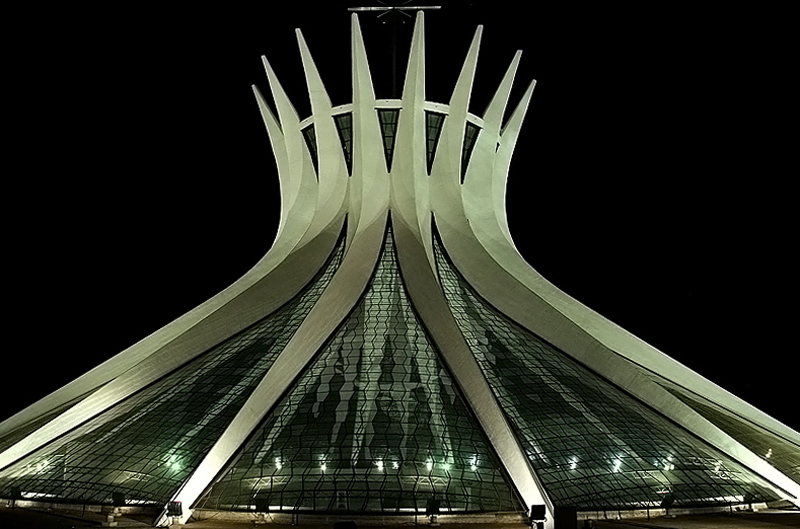What time of day do you think this photo was taken and why? The photo seems to have been taken at night given the dark sky and the artificial lighting accentuating the structure's features. The strategic lighting points highlight the architectural details, suggesting it was important to capture the mood and drama of the building against the night sky. 